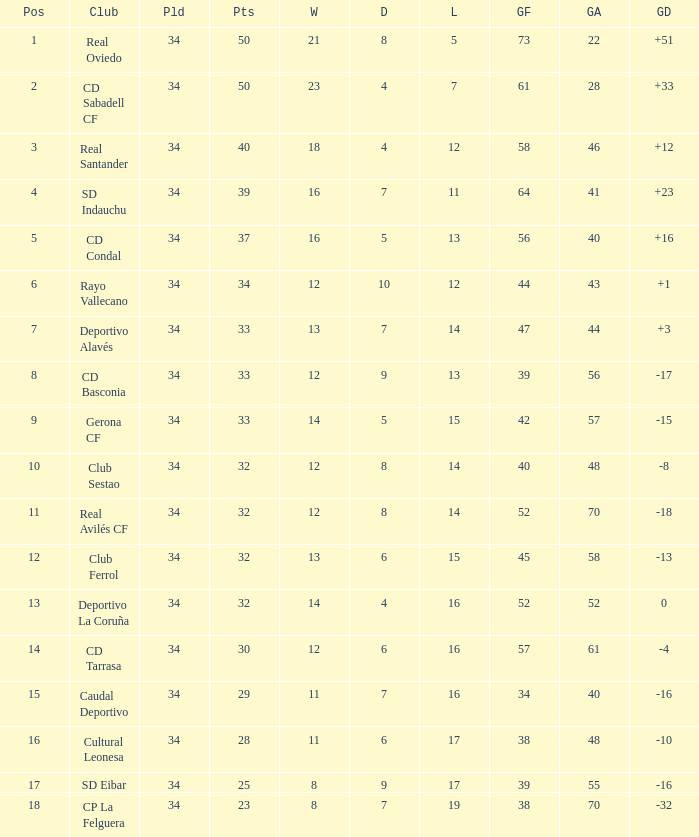How many Goals against have Played more than 34? 0.0. 